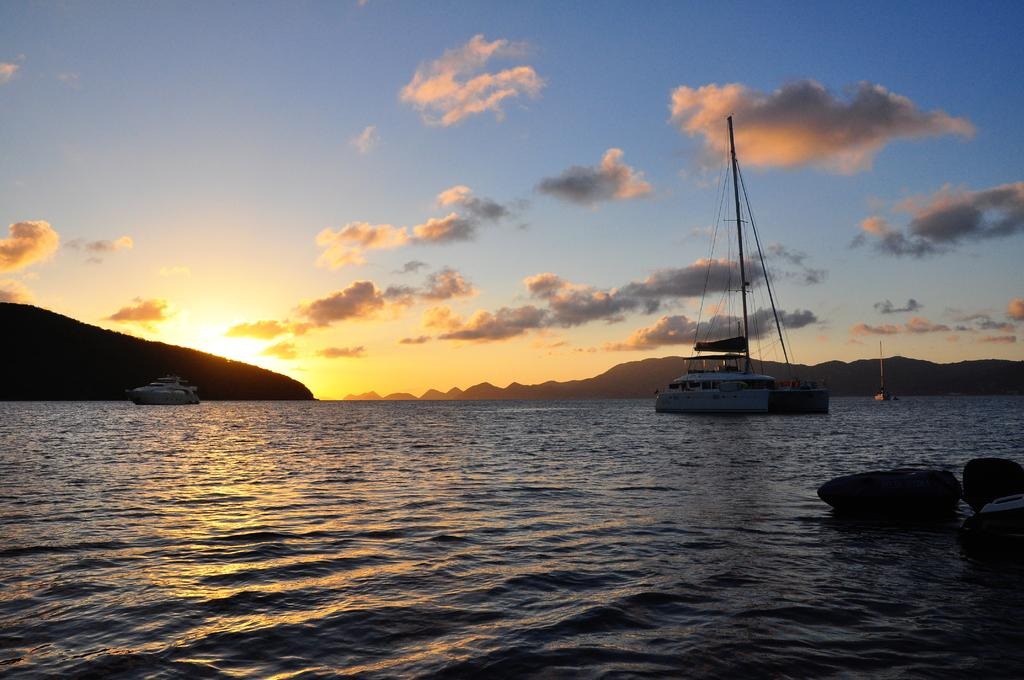What is the main subject of the image? The main subject of the image is boats. Where are the boats located? The boats are on a river. What can be seen in the background of the image? There are mountains and the sky visible in the background of the image. What type of trousers are the trees wearing in the image? There are no trees wearing trousers in the image; trees do not wear clothing. 